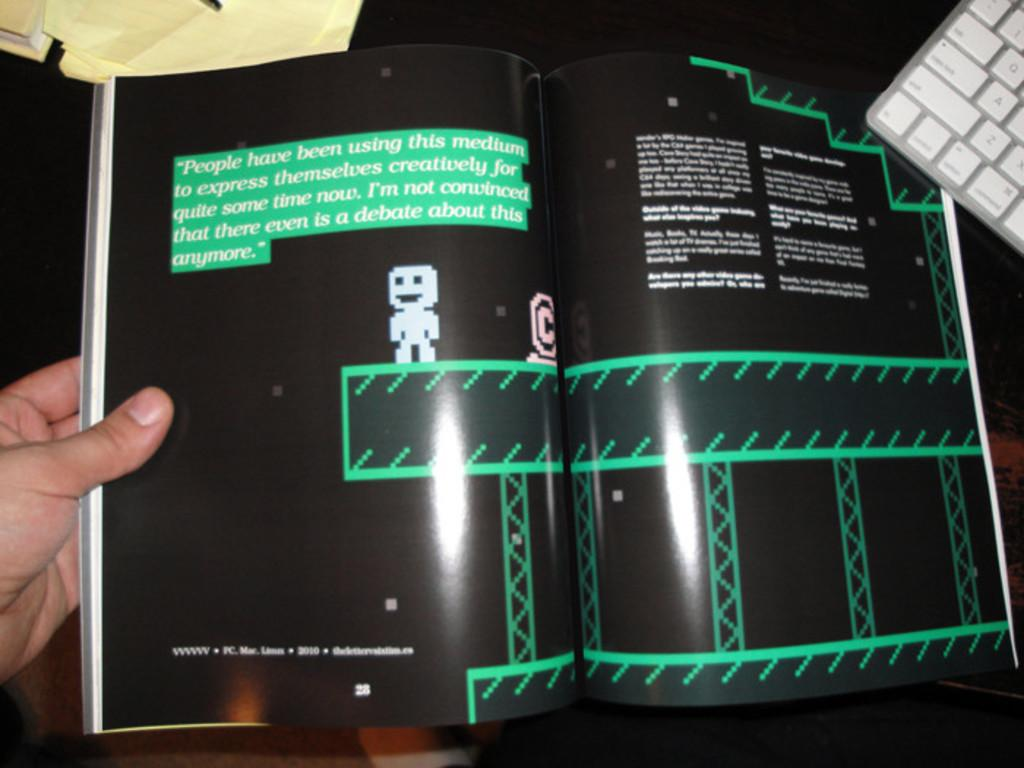<image>
Offer a succinct explanation of the picture presented. "People have been using this medium to express themselves creatively for quite some time now" is printed on the top of this book page. 